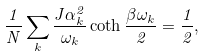Convert formula to latex. <formula><loc_0><loc_0><loc_500><loc_500>\frac { 1 } { N } \sum _ { k } \frac { J \alpha _ { k } ^ { 2 } } { \omega _ { k } } \coth \frac { \beta \omega _ { k } } { 2 } = \frac { 1 } { 2 } ,</formula> 